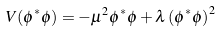Convert formula to latex. <formula><loc_0><loc_0><loc_500><loc_500>V ( \phi ^ { \ast } \phi ) = - \mu ^ { 2 } \phi ^ { \ast } \phi + \lambda \left ( \phi ^ { \ast } \phi \right ) ^ { 2 }</formula> 